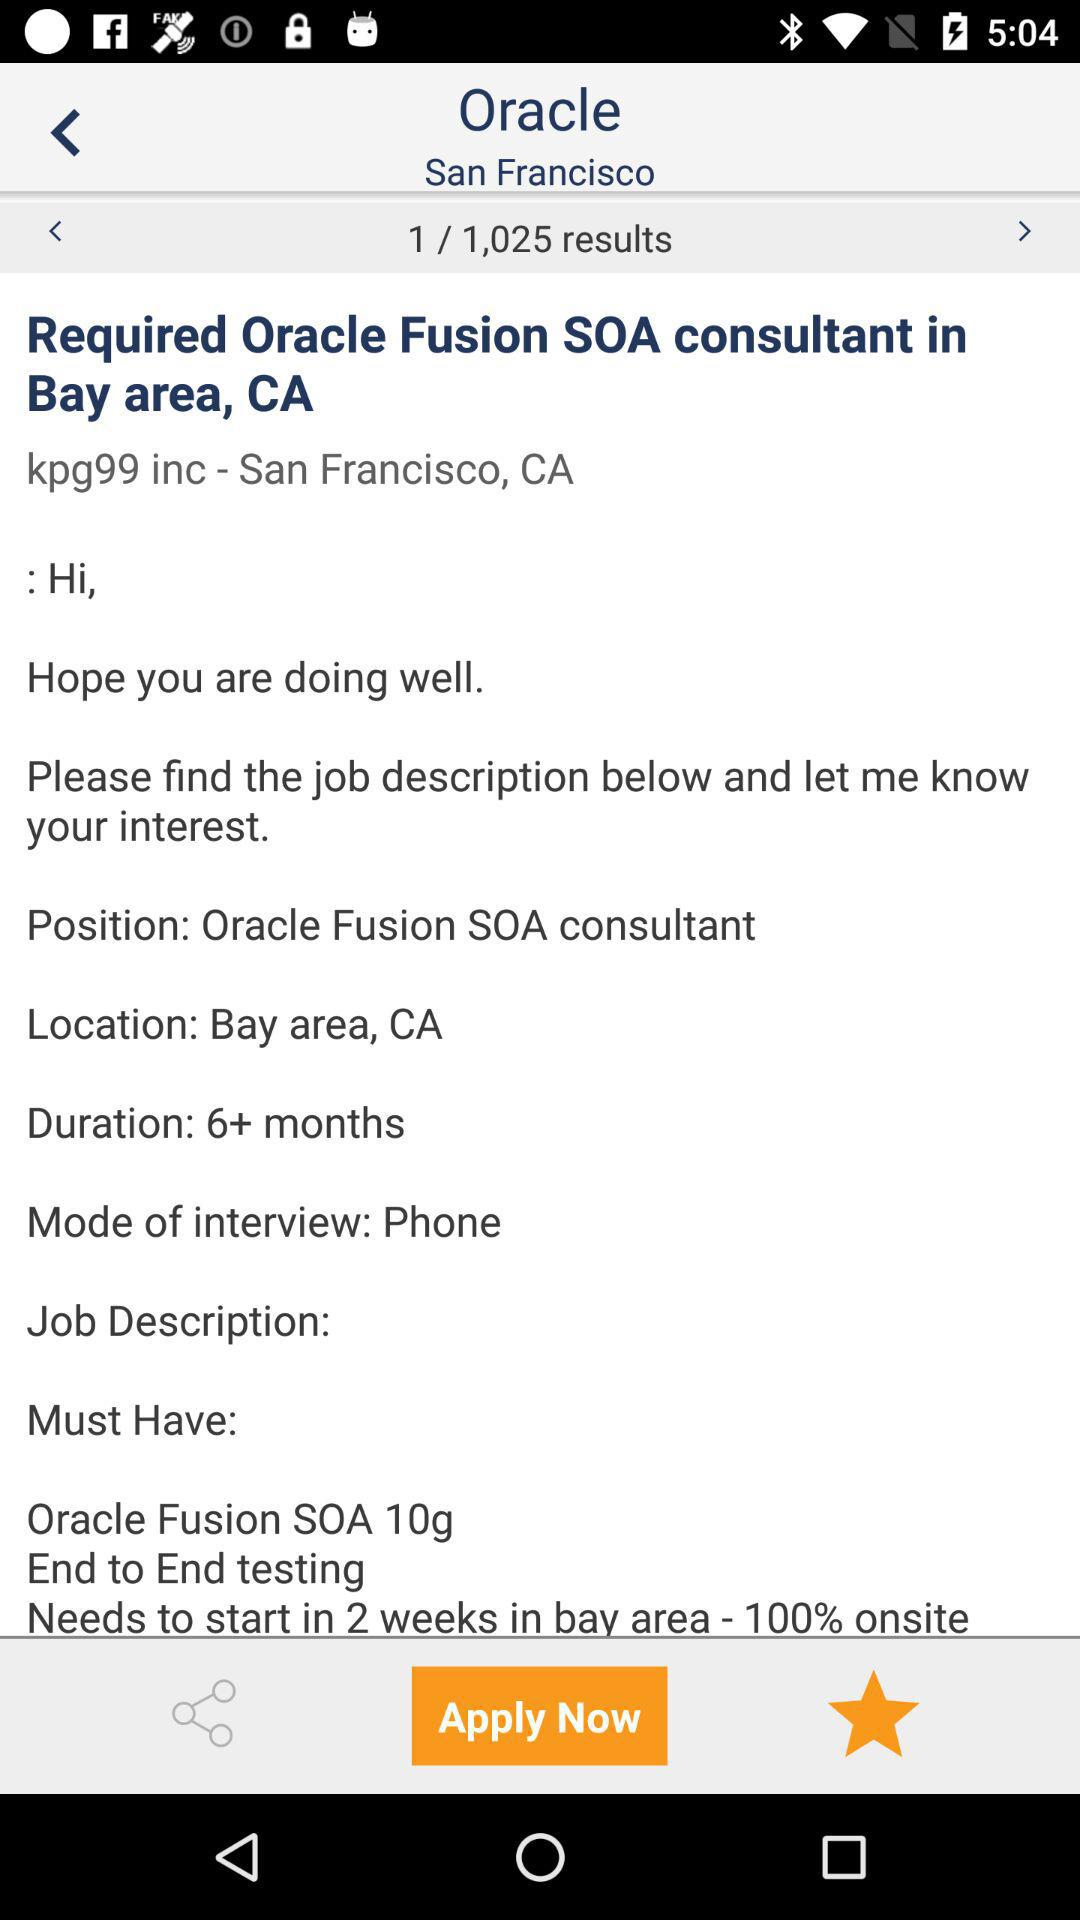How many results are shown on the screen? There is 1 result shown on the screen. 